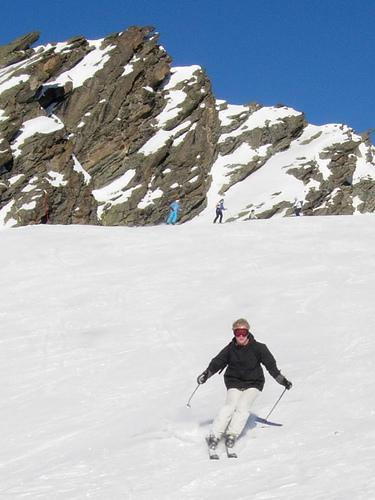Question: why is the woman on the mountain?
Choices:
A. Hiking.
B. Walking.
C. She is skiing.
D. Running.
Answer with the letter. Answer: C Question: when is this taken?
Choices:
A. At night.
B. Morning.
C. During the day.
D. Afternoon.
Answer with the letter. Answer: C Question: who is skiing?
Choices:
A. The kids.
B. The mom.
C. The woman.
D. The dad.
Answer with the letter. Answer: C 